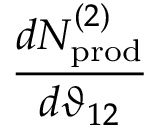<formula> <loc_0><loc_0><loc_500><loc_500>\frac { d N _ { p r o d } ^ { ( 2 ) } } { d \vartheta _ { 1 2 } }</formula> 